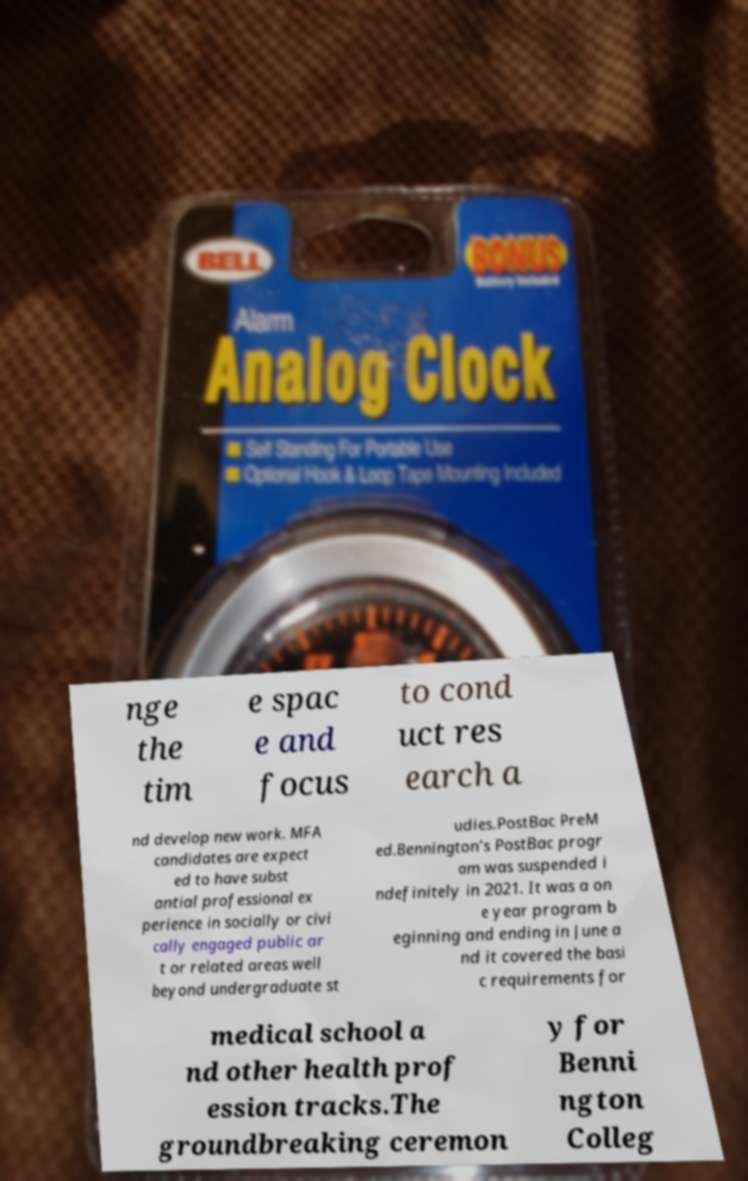Please identify and transcribe the text found in this image. nge the tim e spac e and focus to cond uct res earch a nd develop new work. MFA candidates are expect ed to have subst antial professional ex perience in socially or civi cally engaged public ar t or related areas well beyond undergraduate st udies.PostBac PreM ed.Bennington’s PostBac progr am was suspended i ndefinitely in 2021. It was a on e year program b eginning and ending in June a nd it covered the basi c requirements for medical school a nd other health prof ession tracks.The groundbreaking ceremon y for Benni ngton Colleg 